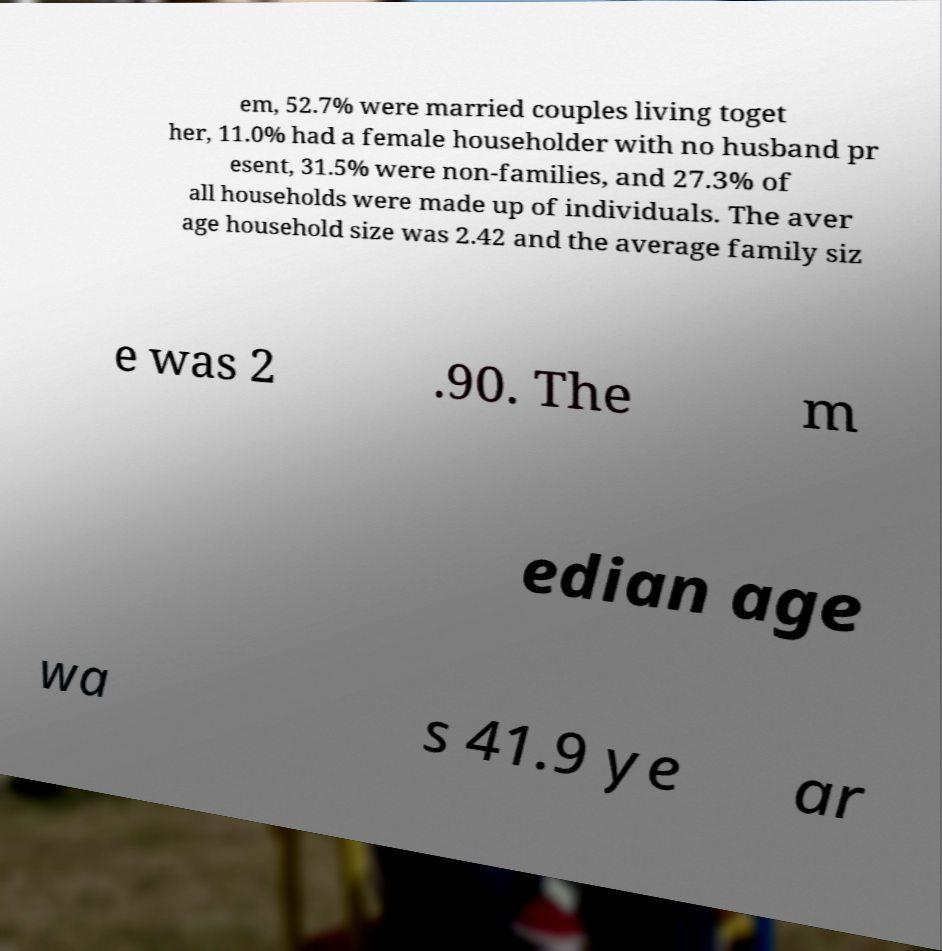Can you accurately transcribe the text from the provided image for me? em, 52.7% were married couples living toget her, 11.0% had a female householder with no husband pr esent, 31.5% were non-families, and 27.3% of all households were made up of individuals. The aver age household size was 2.42 and the average family siz e was 2 .90. The m edian age wa s 41.9 ye ar 